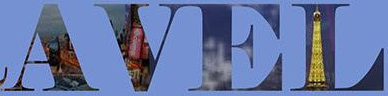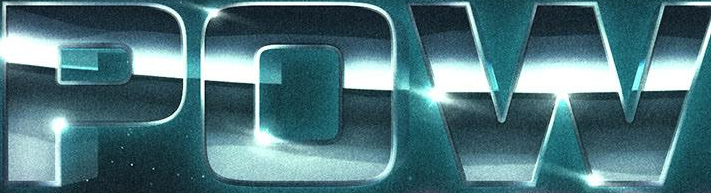Read the text content from these images in order, separated by a semicolon. AVEL; POW 